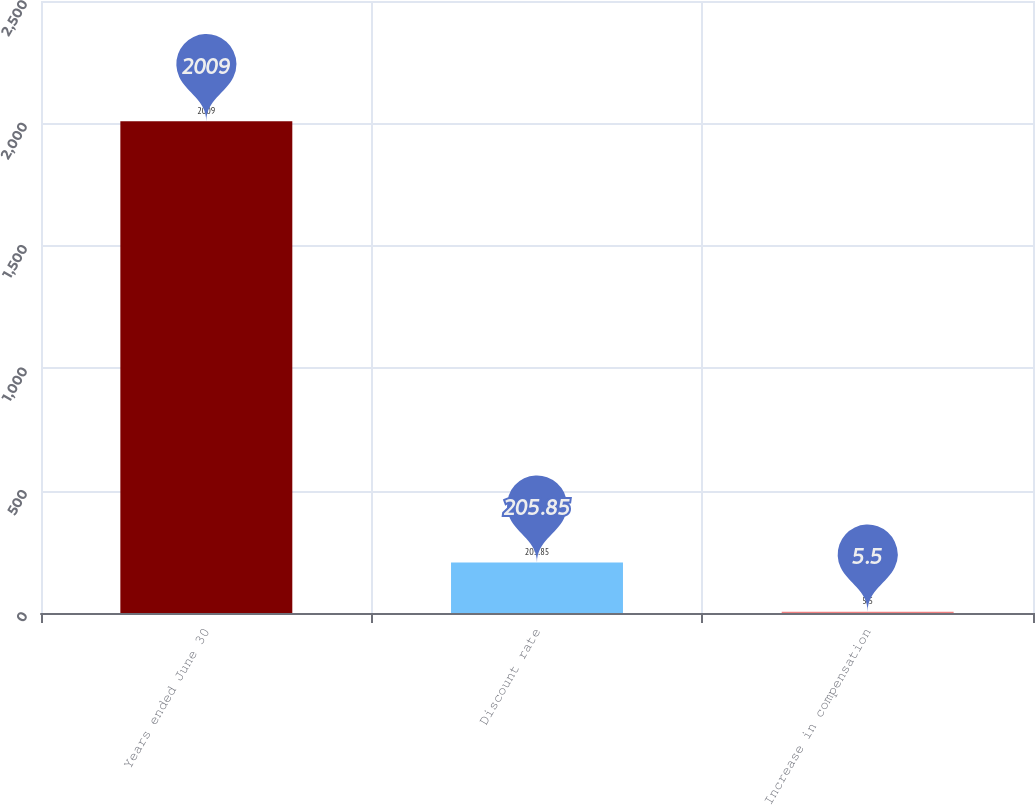<chart> <loc_0><loc_0><loc_500><loc_500><bar_chart><fcel>Years ended June 30<fcel>Discount rate<fcel>Increase in compensation<nl><fcel>2009<fcel>205.85<fcel>5.5<nl></chart> 